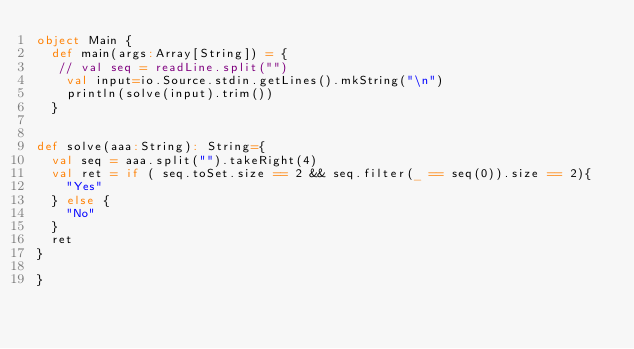<code> <loc_0><loc_0><loc_500><loc_500><_Scala_>object Main {
  def main(args:Array[String]) = {
   // val seq = readLine.split("")
    val input=io.Source.stdin.getLines().mkString("\n")
    println(solve(input).trim())
  }


def solve(aaa:String): String={
  val seq = aaa.split("").takeRight(4)
  val ret = if ( seq.toSet.size == 2 && seq.filter(_ == seq(0)).size == 2){
    "Yes"
  } else {
    "No"
  }
  ret
}

}
</code> 